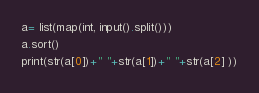Convert code to text. <code><loc_0><loc_0><loc_500><loc_500><_Python_>a= list(map(int, input().split()))
a.sort()
print(str(a[0])+" "+str(a[1])+" "+str(a[2] ))
</code> 